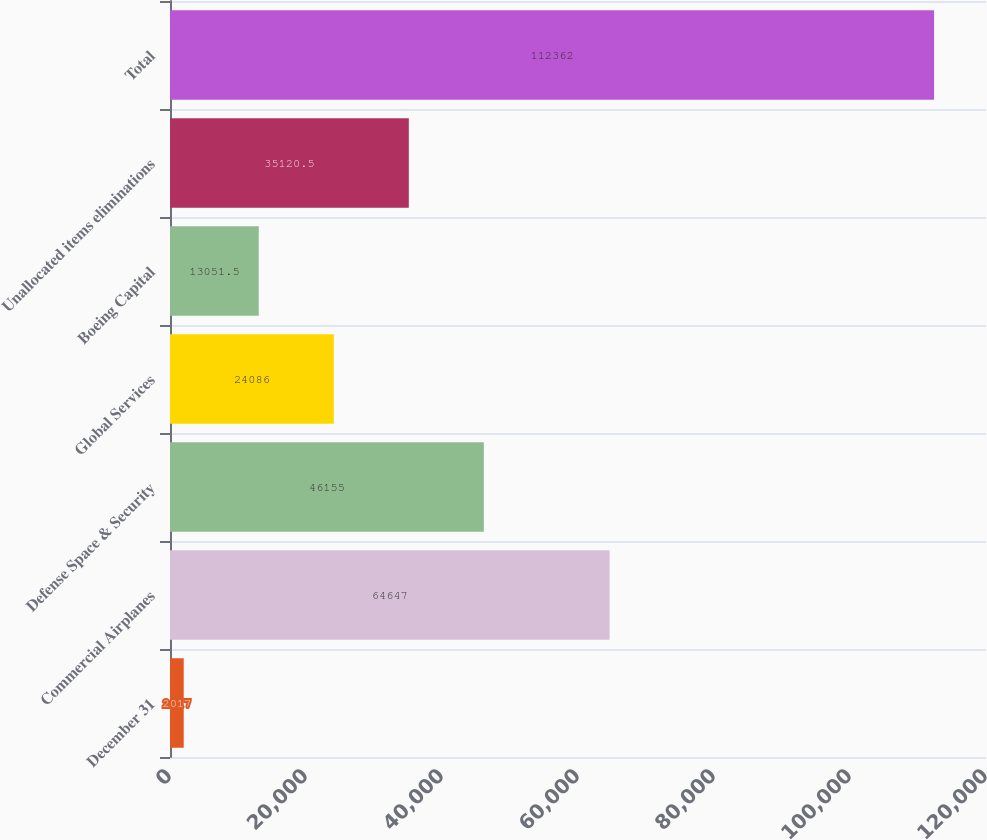Convert chart. <chart><loc_0><loc_0><loc_500><loc_500><bar_chart><fcel>December 31<fcel>Commercial Airplanes<fcel>Defense Space & Security<fcel>Global Services<fcel>Boeing Capital<fcel>Unallocated items eliminations<fcel>Total<nl><fcel>2017<fcel>64647<fcel>46155<fcel>24086<fcel>13051.5<fcel>35120.5<fcel>112362<nl></chart> 